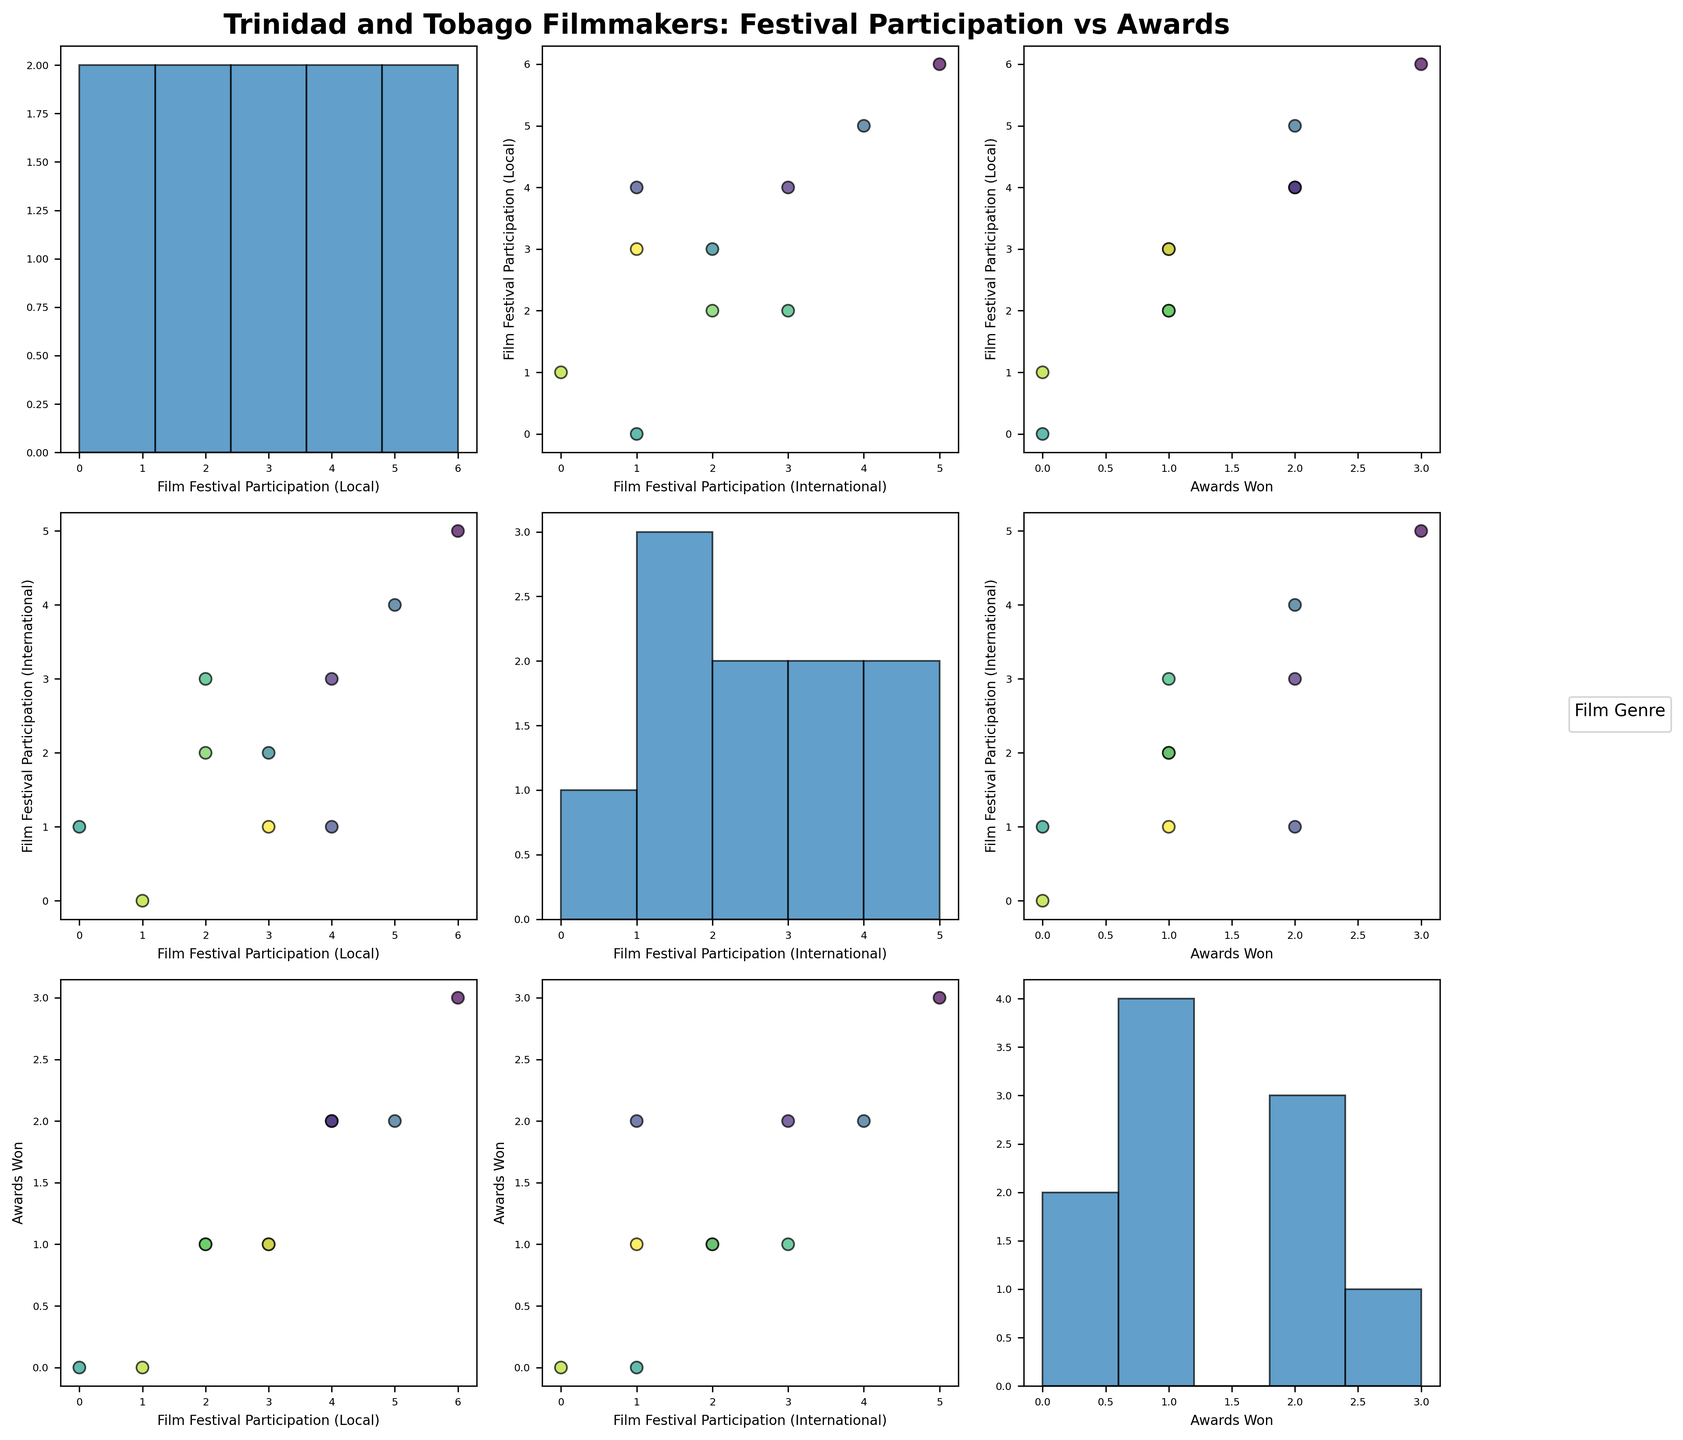Which filmmaker participated in the most local festivals? Find the filmmaker with the highest value on the "Film Festival Participation (Local)" axis in the diagonal histogram plots. The highest value is 6, which belongs to Christopher Laird.
Answer: Christopher Laird Which two genres have the highest awards won combined? Identify the genres for different points and add their respective "Awards Won" values. Drama (1) + Documentary (2) + Comedy (2) + Horror (1) + Action (3) + Romance (0) + Thriller (1) + Mystery (1) + Fantasy (0) + Adventure (2). The highest combined awards are for Action (3) and Comedy/Adventure (2 each).
Answer: Action and Comedy (or Action and Adventure) What is the relationship between local and international festival participation for fantasy films? Look at points representing fantasy films (color-coded) on the scatter plots comparing local and international festival participation. The fantasy film "Dreams in the Moonlight" participated in 0 local festivals and 1 international festival.
Answer: 0 local, 1 international Which genre has no international festival participation at all? Identify the genre of points where "Film Festival Participation (International)" is 0 on the relevant scatter plot and histogram. The genre with 0 international participation is Romance.
Answer: Romance Do filmmakers with higher local festival participation tend to win more awards? Check the scatter plot where "Film Festival Participation (Local)" is on one axis and "Awards Won" is on the other. The general trend should indicate if higher local participation correlates with more awards. Most points follow an upward trend.
Answer: Yes How many awards were won by horror and thriller films combined? Find the individual "Awards Won" for Horror (The Cutlass: 1) and Thriller (The Mischievous Winky: 1) films, then sum them up.
Answer: 2 How is the relationship between international festival participation and awards won depicted for action films? Identify action film points on the scatter plot between "Film Festival Participation (International)" and "Awards Won". "Jab! The Blue Devils of Paramin" participated in 5 international festivals and won 3 awards.
Answer: 5 international, 3 awards What is the average local festival participation for filmmakers who won 2 awards? Identify filmmakers who won 2 awards, then find and average their "Film Festival Participation (Local)" values. Filmmakers with 2 awards are Frances-Anne Solomon (5 local), Michael Mooleedhar (4 local), and Miquel Galofre (4 local). (5+4+4)/3 = 4.33
Answer: 4.33 Which filmmaker had the highest participation in both local and international festivals combined? Sum "Film Festival Participation (Local)" and "Film Festival Participation (International)" for each filmmaker, then find the highest sum. Christopher Laird has the highest with 6 local + 5 international = 11 festivals.
Answer: Christopher Laird 